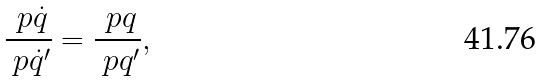Convert formula to latex. <formula><loc_0><loc_0><loc_500><loc_500>\frac { \ p \dot { q } } { \ p \dot { q } ^ { \prime } } = \frac { \ p q } { \ p q ^ { \prime } } ,</formula> 